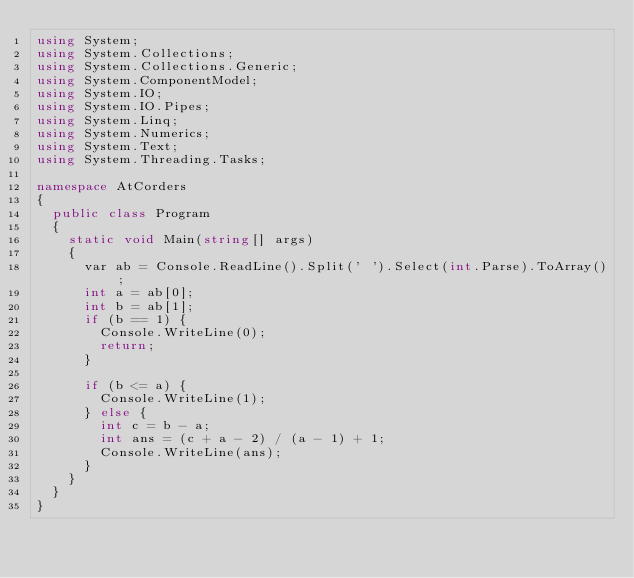Convert code to text. <code><loc_0><loc_0><loc_500><loc_500><_C#_>using System;
using System.Collections;
using System.Collections.Generic;
using System.ComponentModel;
using System.IO;
using System.IO.Pipes;
using System.Linq;
using System.Numerics;
using System.Text;
using System.Threading.Tasks;

namespace AtCorders
{
	public class Program
	{
		static void Main(string[] args)
		{
			var ab = Console.ReadLine().Split(' ').Select(int.Parse).ToArray();
			int a = ab[0];
			int b = ab[1];
			if (b == 1) {
				Console.WriteLine(0);
				return;
			}

			if (b <= a) {
				Console.WriteLine(1);
			} else {
				int c = b - a;
				int ans = (c + a - 2) / (a - 1) + 1;
				Console.WriteLine(ans);
			}
		}
	}
}</code> 